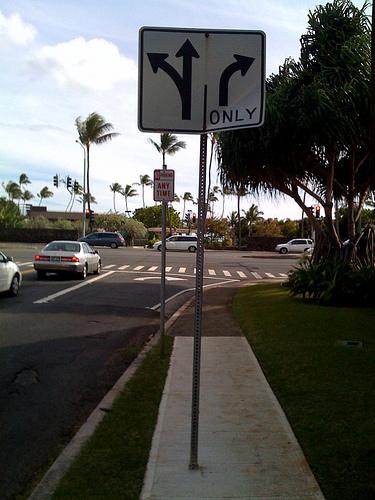Do these arrows indicate there is an option to go straight?
Quick response, please. Yes. Is it sunny?
Keep it brief. Yes. Should I be stopping here?
Be succinct. No. Which three directions are allowed at this intersection?
Write a very short answer. Left straight right. Is this a two way street?
Be succinct. Yes. What should drivers do when they see this sign?
Answer briefly. Turn. Is there a lot of traffic?
Keep it brief. No. What kind of trees are the tall ones in the background?
Keep it brief. Palm. What shape is this sign?
Be succinct. Rectangle. 